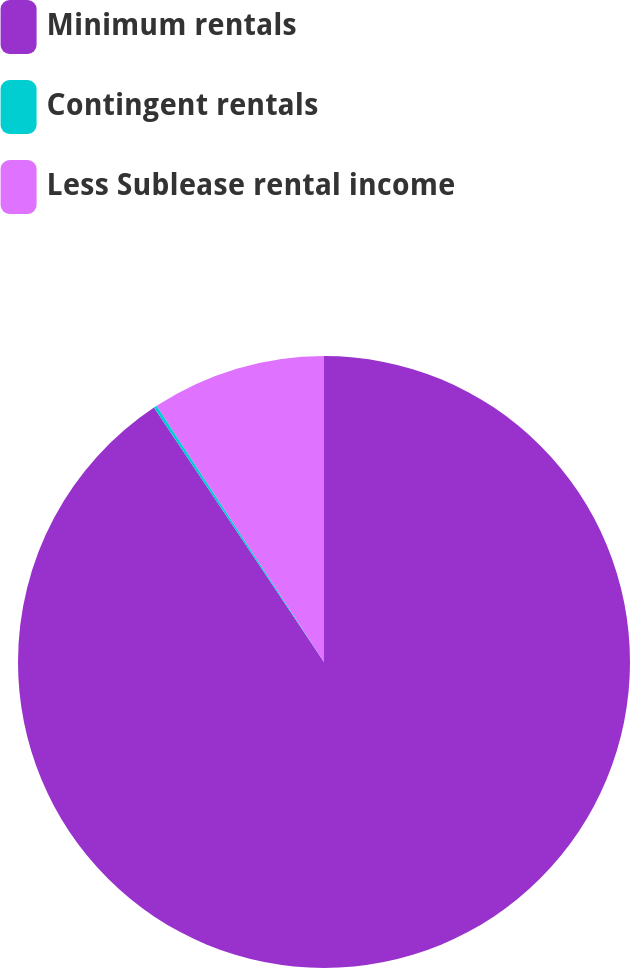Convert chart. <chart><loc_0><loc_0><loc_500><loc_500><pie_chart><fcel>Minimum rentals<fcel>Contingent rentals<fcel>Less Sublease rental income<nl><fcel>90.62%<fcel>0.17%<fcel>9.21%<nl></chart> 